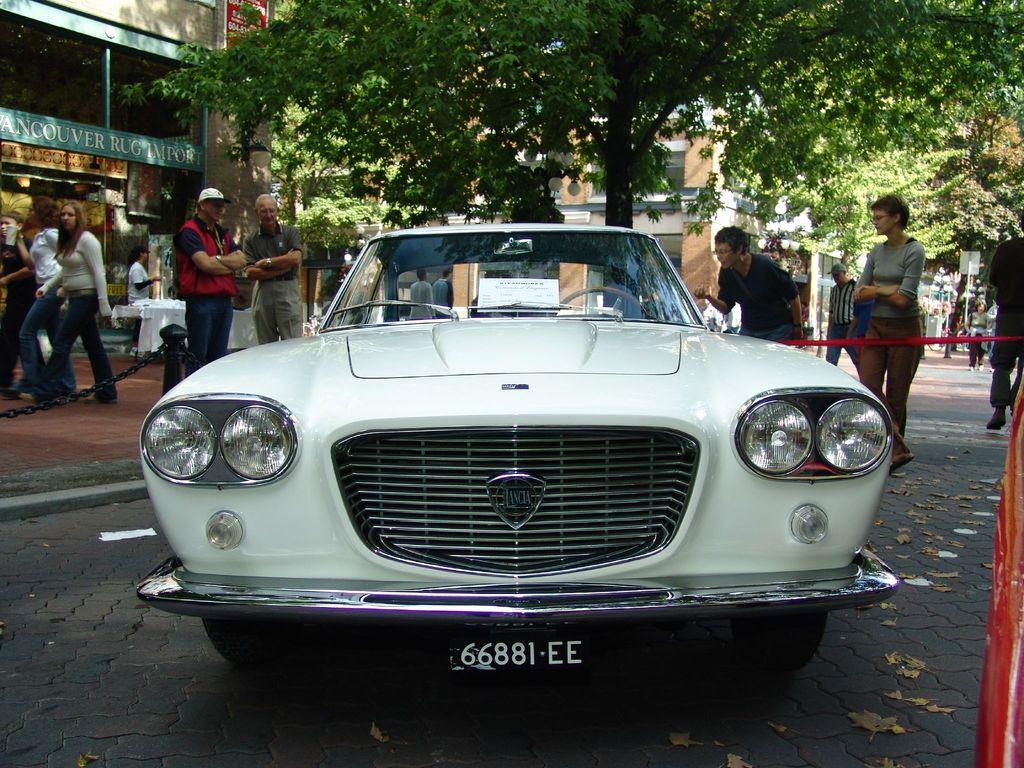What is the color of the vehicle in the image? The vehicle in the image is white. Where is the vehicle located? The vehicle is on the road. What can be seen in the background of the image? There are persons, trees, and buildings in the background of the image. What type of punishment is being given to the vehicle in the image? There is no punishment being given to the vehicle in the image; it is simply a vehicle on the road. 